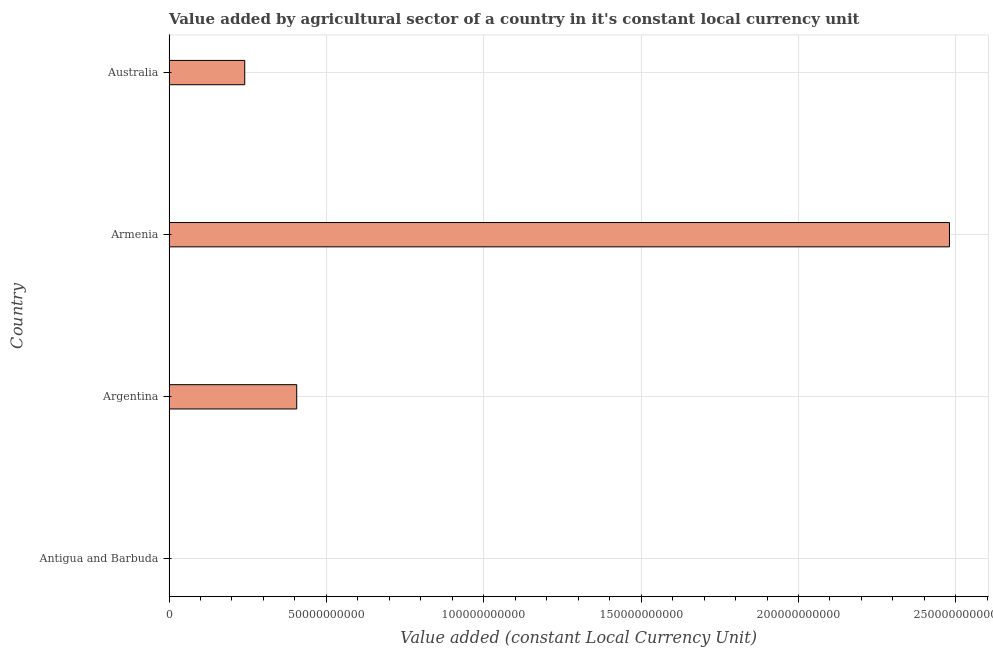Does the graph contain any zero values?
Your response must be concise. No. Does the graph contain grids?
Provide a succinct answer. Yes. What is the title of the graph?
Keep it short and to the point. Value added by agricultural sector of a country in it's constant local currency unit. What is the label or title of the X-axis?
Provide a short and direct response. Value added (constant Local Currency Unit). What is the value added by agriculture sector in Argentina?
Offer a very short reply. 4.06e+1. Across all countries, what is the maximum value added by agriculture sector?
Provide a succinct answer. 2.48e+11. Across all countries, what is the minimum value added by agriculture sector?
Your response must be concise. 4.30e+07. In which country was the value added by agriculture sector maximum?
Provide a short and direct response. Armenia. In which country was the value added by agriculture sector minimum?
Your response must be concise. Antigua and Barbuda. What is the sum of the value added by agriculture sector?
Make the answer very short. 3.13e+11. What is the difference between the value added by agriculture sector in Argentina and Armenia?
Your answer should be compact. -2.07e+11. What is the average value added by agriculture sector per country?
Provide a short and direct response. 7.82e+1. What is the median value added by agriculture sector?
Keep it short and to the point. 3.23e+1. Is the value added by agriculture sector in Armenia less than that in Australia?
Keep it short and to the point. No. Is the difference between the value added by agriculture sector in Argentina and Australia greater than the difference between any two countries?
Offer a very short reply. No. What is the difference between the highest and the second highest value added by agriculture sector?
Your answer should be compact. 2.07e+11. Is the sum of the value added by agriculture sector in Armenia and Australia greater than the maximum value added by agriculture sector across all countries?
Provide a short and direct response. Yes. What is the difference between the highest and the lowest value added by agriculture sector?
Ensure brevity in your answer.  2.48e+11. In how many countries, is the value added by agriculture sector greater than the average value added by agriculture sector taken over all countries?
Your response must be concise. 1. How many bars are there?
Ensure brevity in your answer.  4. Are all the bars in the graph horizontal?
Ensure brevity in your answer.  Yes. How many countries are there in the graph?
Ensure brevity in your answer.  4. Are the values on the major ticks of X-axis written in scientific E-notation?
Your response must be concise. No. What is the Value added (constant Local Currency Unit) of Antigua and Barbuda?
Make the answer very short. 4.30e+07. What is the Value added (constant Local Currency Unit) in Argentina?
Give a very brief answer. 4.06e+1. What is the Value added (constant Local Currency Unit) in Armenia?
Give a very brief answer. 2.48e+11. What is the Value added (constant Local Currency Unit) in Australia?
Make the answer very short. 2.41e+1. What is the difference between the Value added (constant Local Currency Unit) in Antigua and Barbuda and Argentina?
Your answer should be very brief. -4.05e+1. What is the difference between the Value added (constant Local Currency Unit) in Antigua and Barbuda and Armenia?
Your response must be concise. -2.48e+11. What is the difference between the Value added (constant Local Currency Unit) in Antigua and Barbuda and Australia?
Make the answer very short. -2.40e+1. What is the difference between the Value added (constant Local Currency Unit) in Argentina and Armenia?
Provide a succinct answer. -2.07e+11. What is the difference between the Value added (constant Local Currency Unit) in Argentina and Australia?
Your response must be concise. 1.65e+1. What is the difference between the Value added (constant Local Currency Unit) in Armenia and Australia?
Make the answer very short. 2.24e+11. What is the ratio of the Value added (constant Local Currency Unit) in Antigua and Barbuda to that in Argentina?
Your answer should be compact. 0. What is the ratio of the Value added (constant Local Currency Unit) in Antigua and Barbuda to that in Australia?
Provide a short and direct response. 0. What is the ratio of the Value added (constant Local Currency Unit) in Argentina to that in Armenia?
Make the answer very short. 0.16. What is the ratio of the Value added (constant Local Currency Unit) in Argentina to that in Australia?
Provide a succinct answer. 1.69. What is the ratio of the Value added (constant Local Currency Unit) in Armenia to that in Australia?
Your response must be concise. 10.3. 